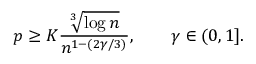Convert formula to latex. <formula><loc_0><loc_0><loc_500><loc_500>p \geq K \frac { \sqrt { [ } 3 ] { \log n } } { n ^ { 1 - ( 2 \gamma / 3 ) } } , \quad \gamma \in ( 0 , 1 ] .</formula> 